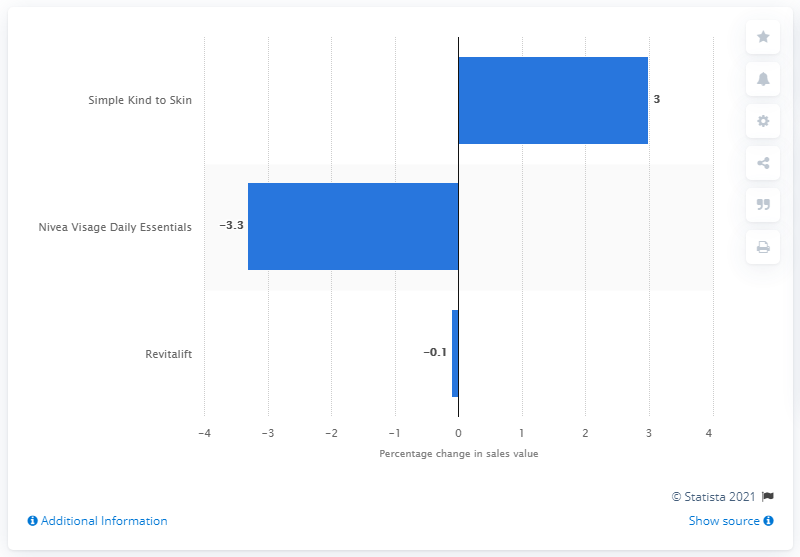Point out several critical features in this image. Simple Kind to Skin is the number one ranking facial skincare brand in the UK. 